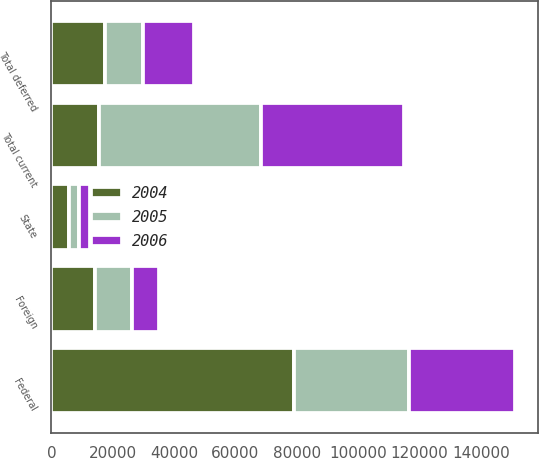<chart> <loc_0><loc_0><loc_500><loc_500><stacked_bar_chart><ecel><fcel>Federal<fcel>State<fcel>Foreign<fcel>Total current<fcel>Total deferred<nl><fcel>2004<fcel>79082<fcel>5837<fcel>14381<fcel>15625<fcel>17516<nl><fcel>2006<fcel>34320<fcel>3436<fcel>8858<fcel>46614<fcel>16869<nl><fcel>2005<fcel>37580<fcel>3268<fcel>11974<fcel>52822<fcel>12188<nl></chart> 